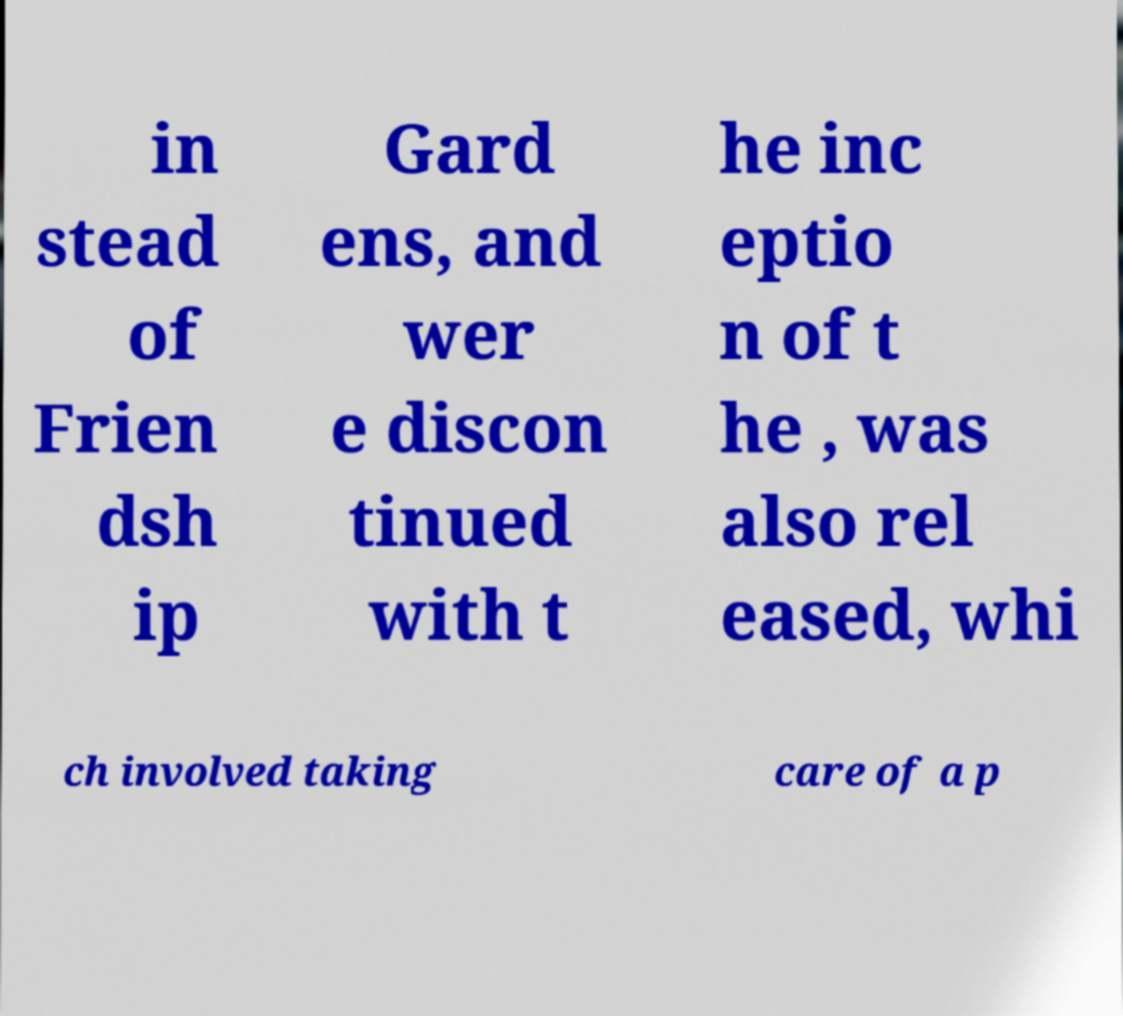Could you assist in decoding the text presented in this image and type it out clearly? in stead of Frien dsh ip Gard ens, and wer e discon tinued with t he inc eptio n of t he , was also rel eased, whi ch involved taking care of a p 